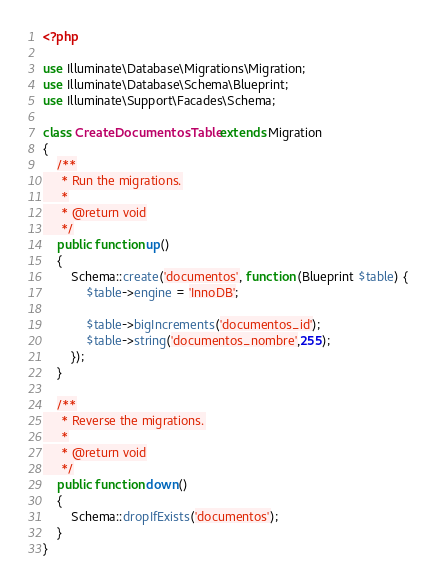<code> <loc_0><loc_0><loc_500><loc_500><_PHP_><?php

use Illuminate\Database\Migrations\Migration;
use Illuminate\Database\Schema\Blueprint;
use Illuminate\Support\Facades\Schema;

class CreateDocumentosTable extends Migration
{
    /**
     * Run the migrations.
     *
     * @return void
     */
    public function up()
    {
        Schema::create('documentos', function (Blueprint $table) {
            $table->engine = 'InnoDB';

            $table->bigIncrements('documentos_id');
            $table->string('documentos_nombre',255);
        });
    }

    /**
     * Reverse the migrations.
     *
     * @return void
     */
    public function down()
    {
        Schema::dropIfExists('documentos');
    }
}
</code> 